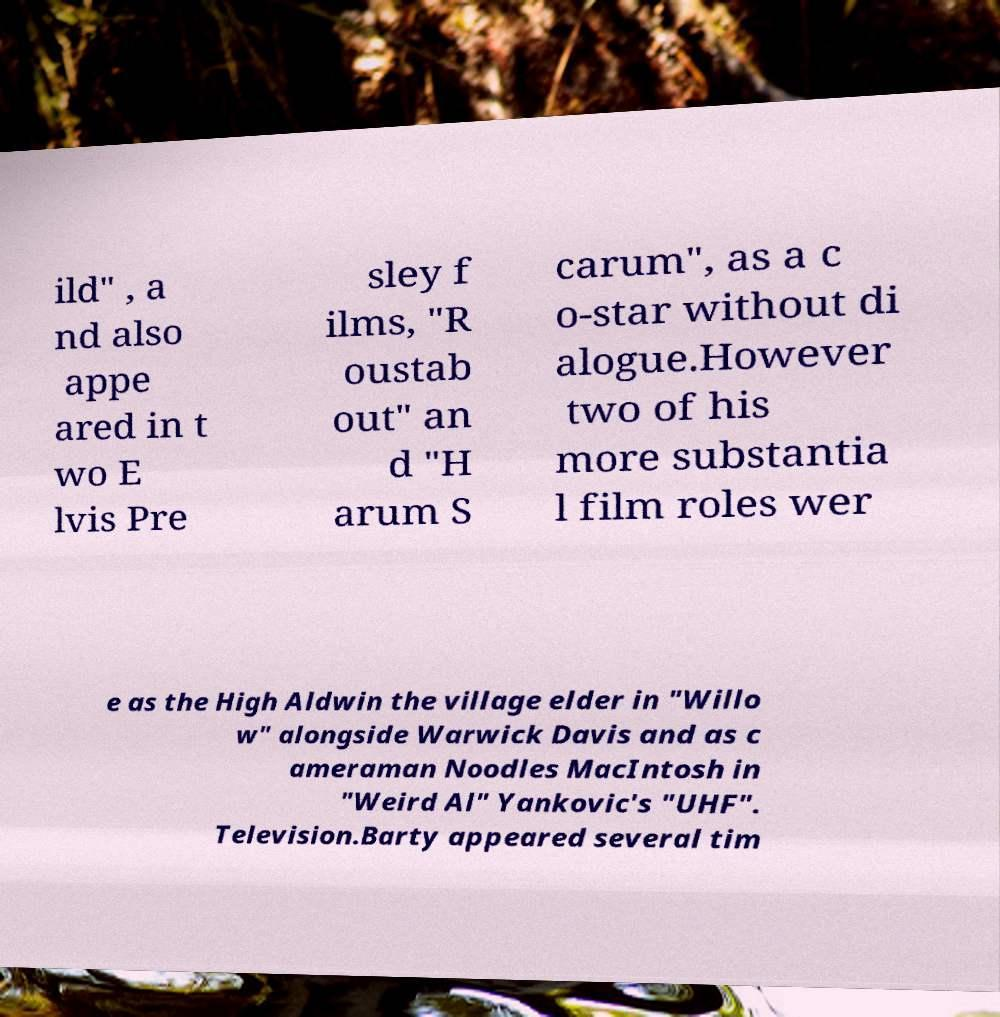What messages or text are displayed in this image? I need them in a readable, typed format. ild" , a nd also appe ared in t wo E lvis Pre sley f ilms, "R oustab out" an d "H arum S carum", as a c o-star without di alogue.However two of his more substantia l film roles wer e as the High Aldwin the village elder in "Willo w" alongside Warwick Davis and as c ameraman Noodles MacIntosh in "Weird Al" Yankovic's "UHF". Television.Barty appeared several tim 